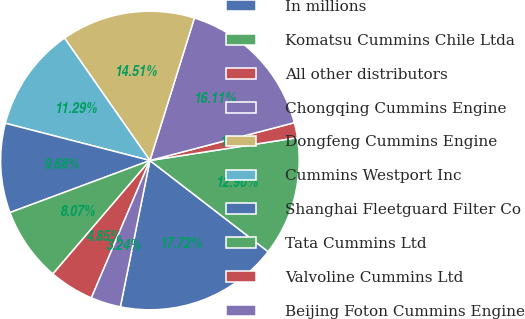<chart> <loc_0><loc_0><loc_500><loc_500><pie_chart><fcel>In millions<fcel>Komatsu Cummins Chile Ltda<fcel>All other distributors<fcel>Chongqing Cummins Engine<fcel>Dongfeng Cummins Engine<fcel>Cummins Westport Inc<fcel>Shanghai Fleetguard Filter Co<fcel>Tata Cummins Ltd<fcel>Valvoline Cummins Ltd<fcel>Beijing Foton Cummins Engine<nl><fcel>17.72%<fcel>12.9%<fcel>1.63%<fcel>16.11%<fcel>14.51%<fcel>11.29%<fcel>9.68%<fcel>8.07%<fcel>4.85%<fcel>3.24%<nl></chart> 